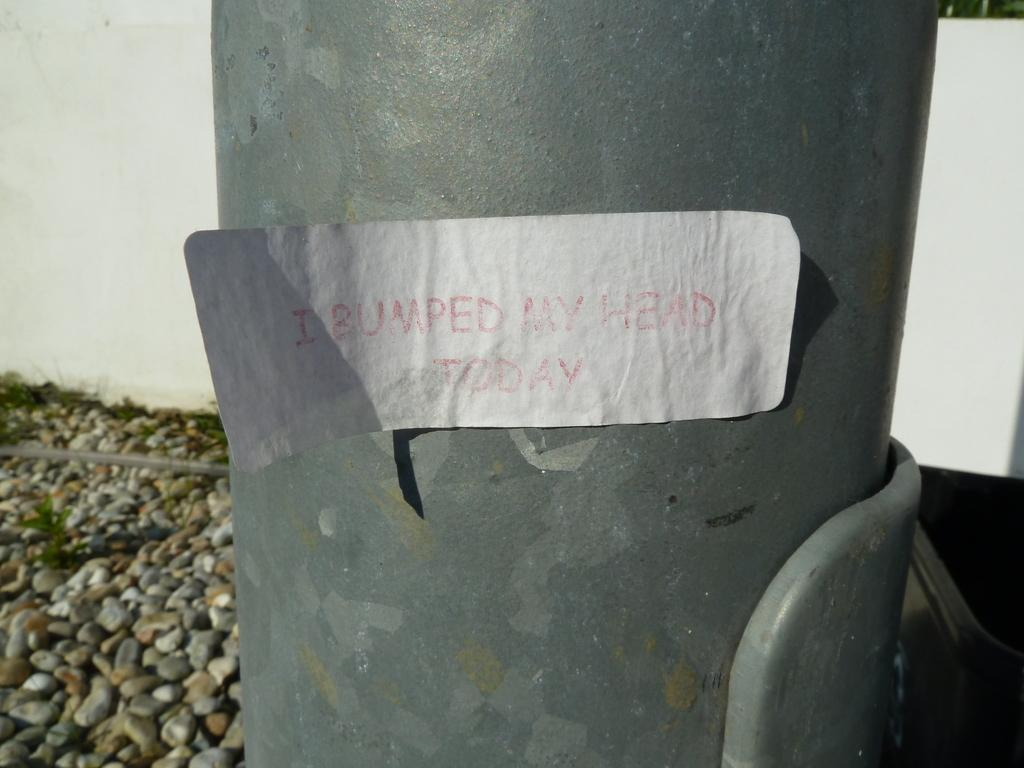What type of pipe is visible in the image? There is a grey color iron pipe in the image. What can be seen in the background of the image? There are small stone pebbles in the background of the image. How does the iron pipe connect to the whistle in the image? There is no whistle present in the image, so it cannot be connected to the iron pipe. 